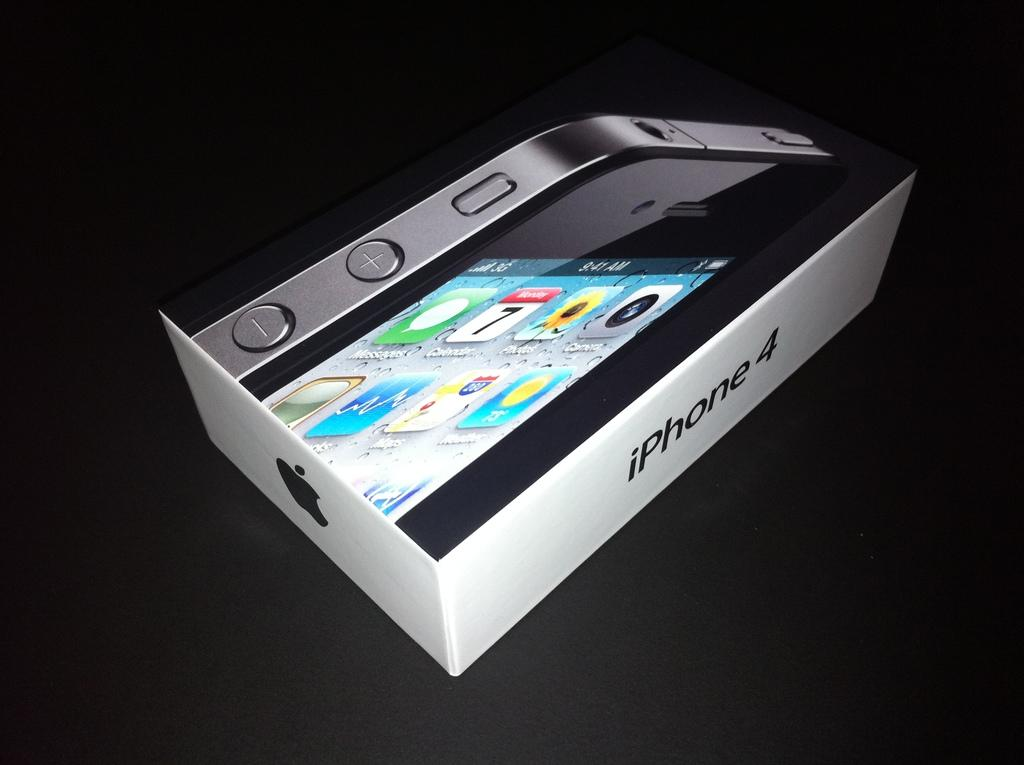What is the main subject of the image? The main subject of the image is an iPhone mobile box. What is the color of the platform the iPhone mobile box is on? The platform is black in color. What type of oatmeal is being prepared in the image? There is no oatmeal or any indication of food preparation in the image; it features an iPhone mobile box on a black platform. How many balls are visible in the image? There are no balls present in the image. 